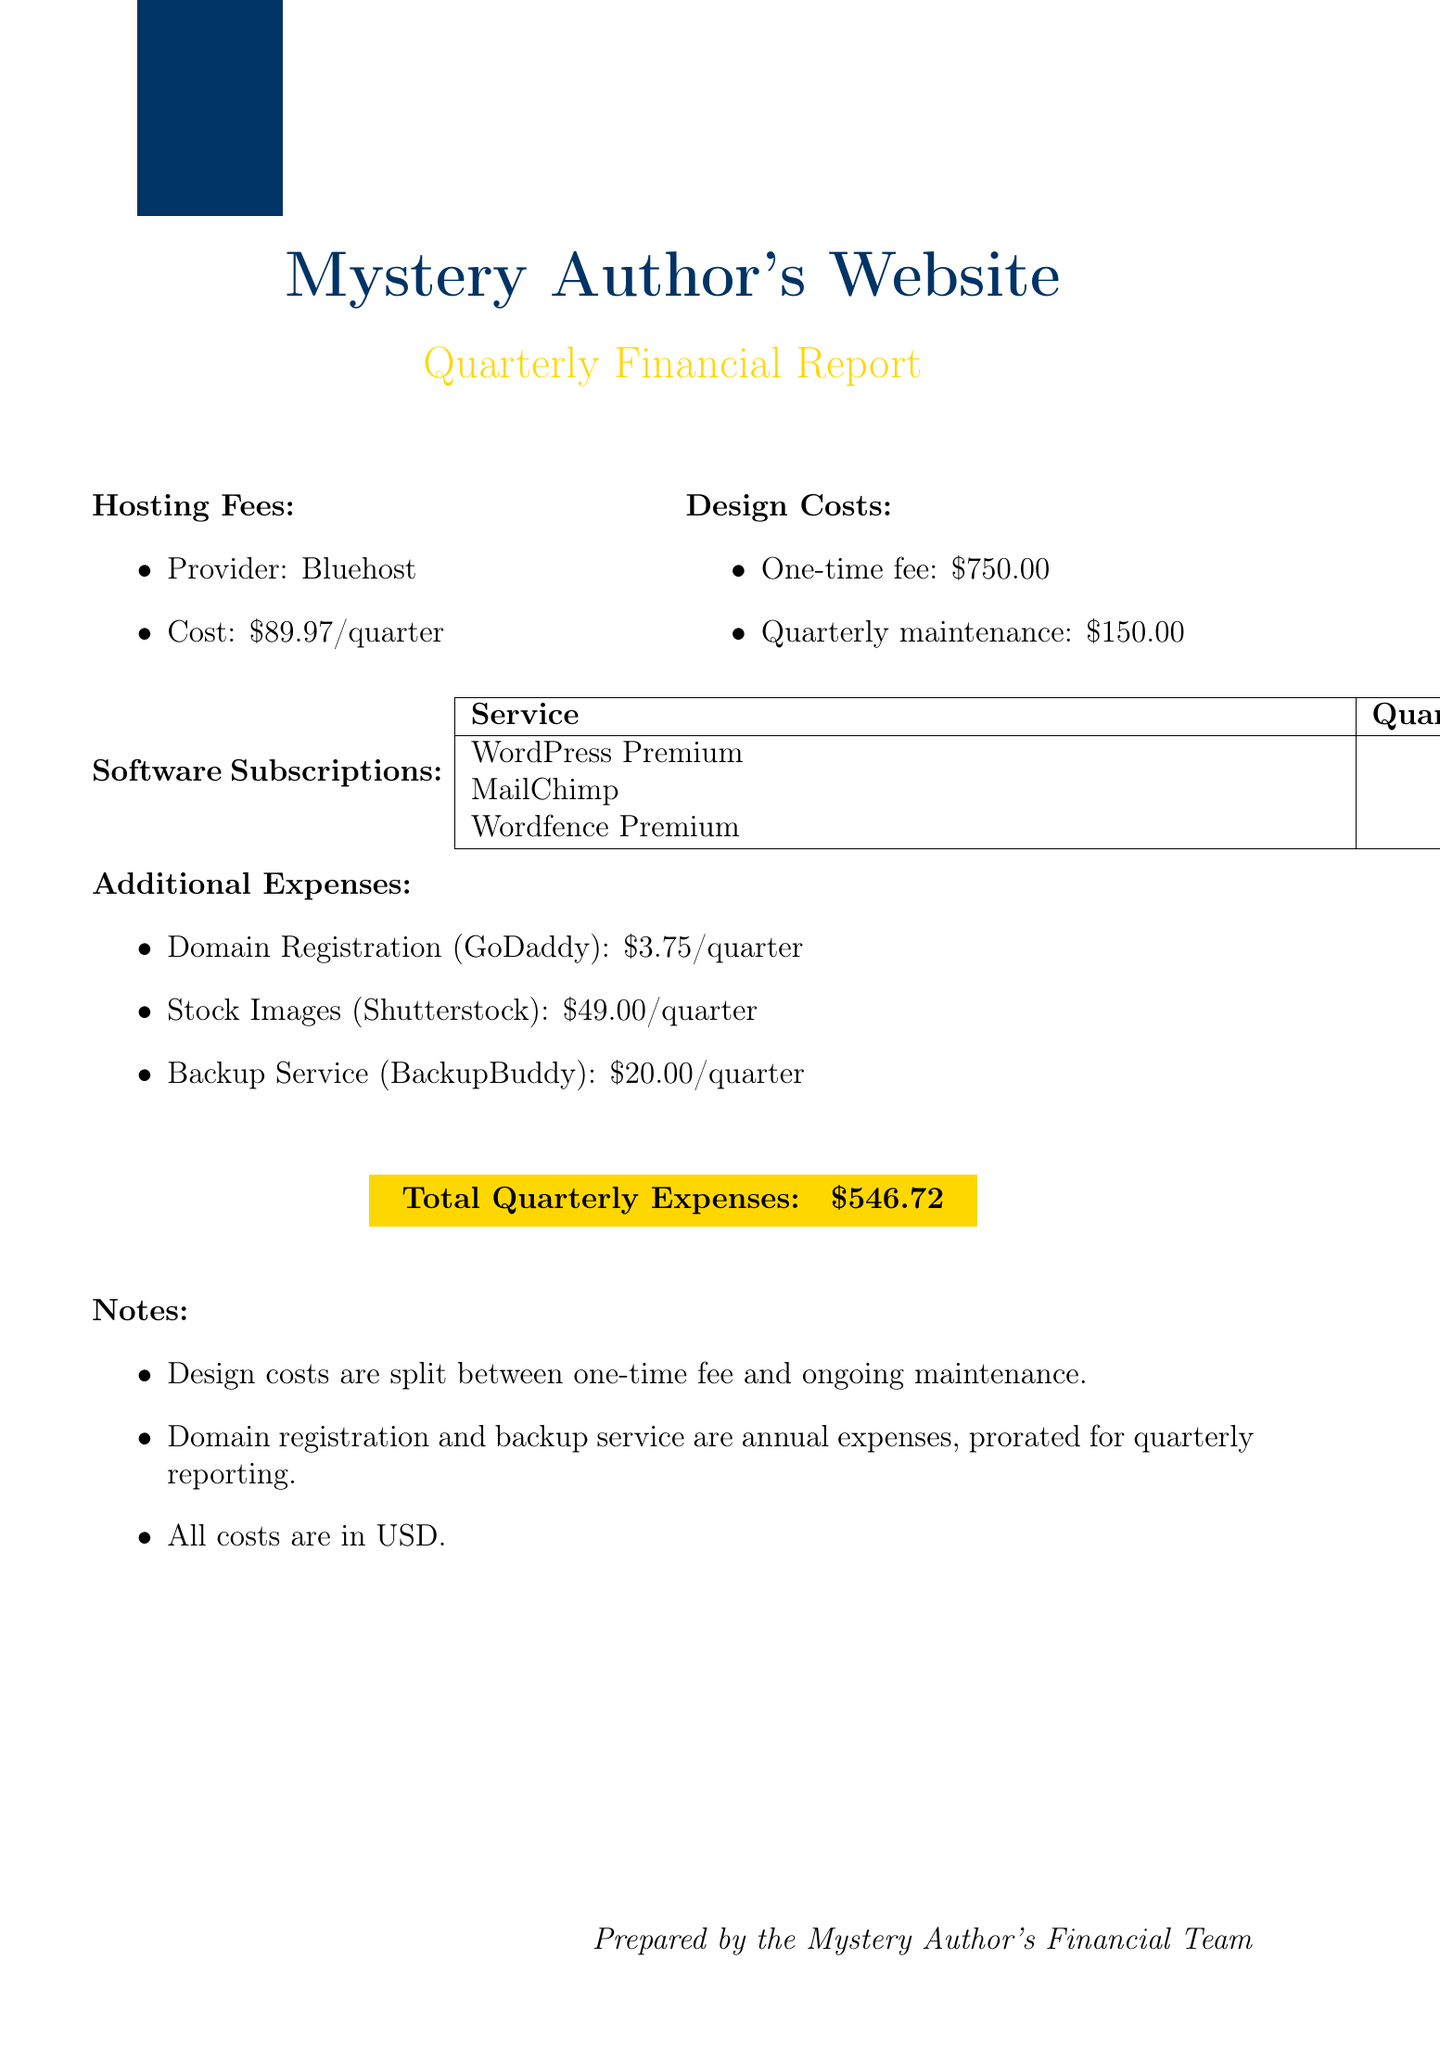what is the quarterly hosting fee? The quarterly hosting fee is listed under hosting fees in the document, which is $89.97.
Answer: $89.97 who is the designer for the one-time design fee? The document specifies that the one-time design fee was paid to Mystery Web Designs.
Answer: Mystery Web Designs what is the total quarterly expense? The total quarterly expenses are clearly stated in the document as $546.72.
Answer: $546.72 how much is the quarterly maintenance cost for design? The document includes the quarterly maintenance cost for design, which is $150.00.
Answer: $150.00 what is the name of the content management software? The document mentions that the content management software is WordPress Premium.
Answer: WordPress Premium how much do stock images cost per quarter? The quarterly cost for stock images is indicated in the additional expenses section, which is $49.00.
Answer: $49.00 how are domain registration costs presented in the report? The document explains that the domain registration cost is an annual expense, outlined as $3.75 per quarter.
Answer: $3.75 what is the annual cost for the backup service? The annual cost for the backup service is stated as $80.00 in the additional expenses section.
Answer: $80.00 which provider is used for hosting? The hosting provider mentioned in the document is Bluehost.
Answer: Bluehost 